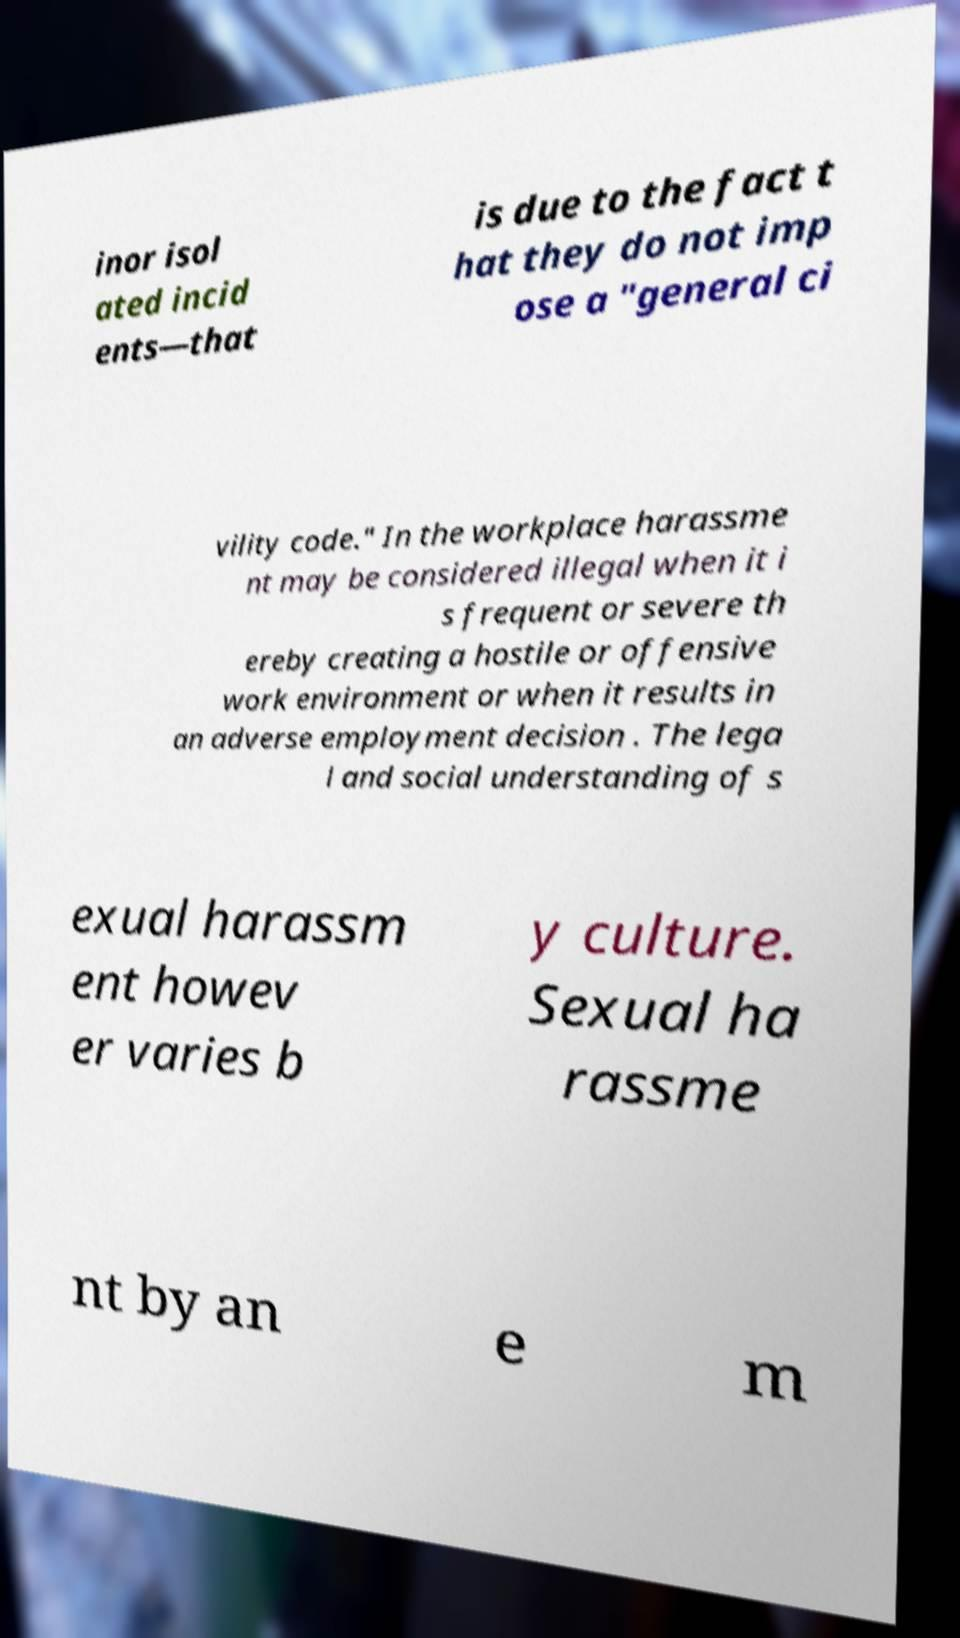What messages or text are displayed in this image? I need them in a readable, typed format. inor isol ated incid ents—that is due to the fact t hat they do not imp ose a "general ci vility code." In the workplace harassme nt may be considered illegal when it i s frequent or severe th ereby creating a hostile or offensive work environment or when it results in an adverse employment decision . The lega l and social understanding of s exual harassm ent howev er varies b y culture. Sexual ha rassme nt by an e m 